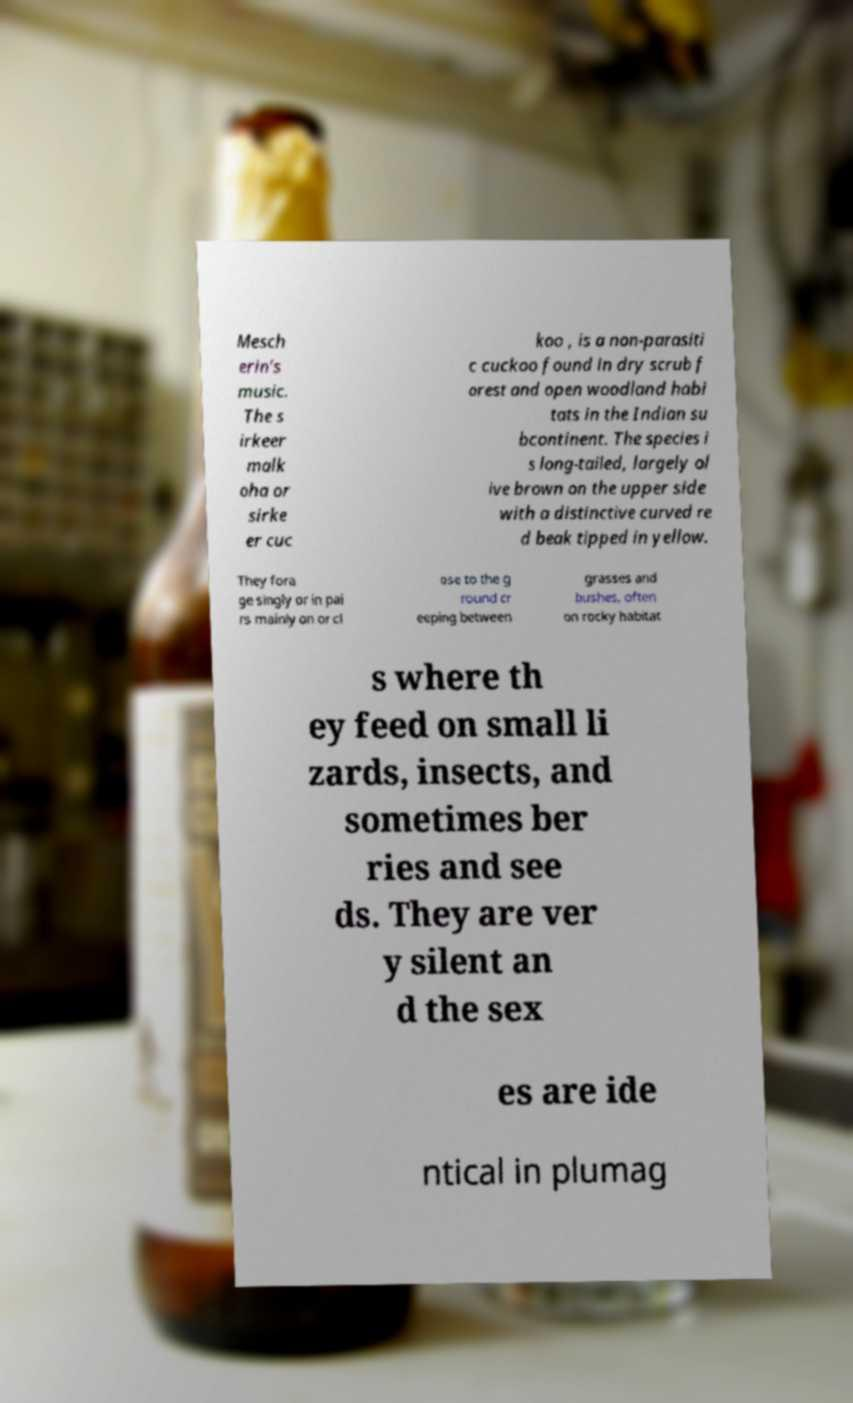I need the written content from this picture converted into text. Can you do that? Mesch erin’s music. The s irkeer malk oha or sirke er cuc koo , is a non-parasiti c cuckoo found in dry scrub f orest and open woodland habi tats in the Indian su bcontinent. The species i s long-tailed, largely ol ive brown on the upper side with a distinctive curved re d beak tipped in yellow. They fora ge singly or in pai rs mainly on or cl ose to the g round cr eeping between grasses and bushes, often on rocky habitat s where th ey feed on small li zards, insects, and sometimes ber ries and see ds. They are ver y silent an d the sex es are ide ntical in plumag 